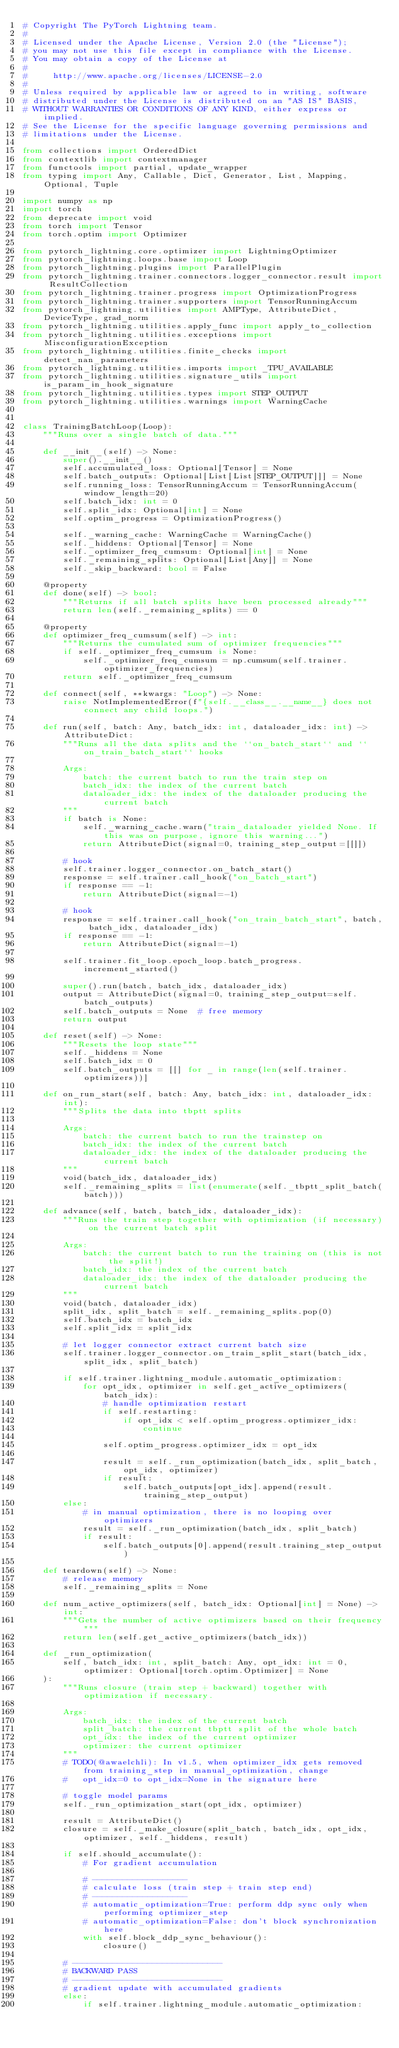<code> <loc_0><loc_0><loc_500><loc_500><_Python_># Copyright The PyTorch Lightning team.
#
# Licensed under the Apache License, Version 2.0 (the "License");
# you may not use this file except in compliance with the License.
# You may obtain a copy of the License at
#
#     http://www.apache.org/licenses/LICENSE-2.0
#
# Unless required by applicable law or agreed to in writing, software
# distributed under the License is distributed on an "AS IS" BASIS,
# WITHOUT WARRANTIES OR CONDITIONS OF ANY KIND, either express or implied.
# See the License for the specific language governing permissions and
# limitations under the License.

from collections import OrderedDict
from contextlib import contextmanager
from functools import partial, update_wrapper
from typing import Any, Callable, Dict, Generator, List, Mapping, Optional, Tuple

import numpy as np
import torch
from deprecate import void
from torch import Tensor
from torch.optim import Optimizer

from pytorch_lightning.core.optimizer import LightningOptimizer
from pytorch_lightning.loops.base import Loop
from pytorch_lightning.plugins import ParallelPlugin
from pytorch_lightning.trainer.connectors.logger_connector.result import ResultCollection
from pytorch_lightning.trainer.progress import OptimizationProgress
from pytorch_lightning.trainer.supporters import TensorRunningAccum
from pytorch_lightning.utilities import AMPType, AttributeDict, DeviceType, grad_norm
from pytorch_lightning.utilities.apply_func import apply_to_collection
from pytorch_lightning.utilities.exceptions import MisconfigurationException
from pytorch_lightning.utilities.finite_checks import detect_nan_parameters
from pytorch_lightning.utilities.imports import _TPU_AVAILABLE
from pytorch_lightning.utilities.signature_utils import is_param_in_hook_signature
from pytorch_lightning.utilities.types import STEP_OUTPUT
from pytorch_lightning.utilities.warnings import WarningCache


class TrainingBatchLoop(Loop):
    """Runs over a single batch of data."""

    def __init__(self) -> None:
        super().__init__()
        self.accumulated_loss: Optional[Tensor] = None
        self.batch_outputs: Optional[List[List[STEP_OUTPUT]]] = None
        self.running_loss: TensorRunningAccum = TensorRunningAccum(window_length=20)
        self.batch_idx: int = 0
        self.split_idx: Optional[int] = None
        self.optim_progress = OptimizationProgress()

        self._warning_cache: WarningCache = WarningCache()
        self._hiddens: Optional[Tensor] = None
        self._optimizer_freq_cumsum: Optional[int] = None
        self._remaining_splits: Optional[List[Any]] = None
        self._skip_backward: bool = False

    @property
    def done(self) -> bool:
        """Returns if all batch splits have been processed already"""
        return len(self._remaining_splits) == 0

    @property
    def optimizer_freq_cumsum(self) -> int:
        """Returns the cumulated sum of optimizer frequencies"""
        if self._optimizer_freq_cumsum is None:
            self._optimizer_freq_cumsum = np.cumsum(self.trainer.optimizer_frequencies)
        return self._optimizer_freq_cumsum

    def connect(self, **kwargs: "Loop") -> None:
        raise NotImplementedError(f"{self.__class__.__name__} does not connect any child loops.")

    def run(self, batch: Any, batch_idx: int, dataloader_idx: int) -> AttributeDict:
        """Runs all the data splits and the ``on_batch_start`` and ``on_train_batch_start`` hooks

        Args:
            batch: the current batch to run the train step on
            batch_idx: the index of the current batch
            dataloader_idx: the index of the dataloader producing the current batch
        """
        if batch is None:
            self._warning_cache.warn("train_dataloader yielded None. If this was on purpose, ignore this warning...")
            return AttributeDict(signal=0, training_step_output=[[]])

        # hook
        self.trainer.logger_connector.on_batch_start()
        response = self.trainer.call_hook("on_batch_start")
        if response == -1:
            return AttributeDict(signal=-1)

        # hook
        response = self.trainer.call_hook("on_train_batch_start", batch, batch_idx, dataloader_idx)
        if response == -1:
            return AttributeDict(signal=-1)

        self.trainer.fit_loop.epoch_loop.batch_progress.increment_started()

        super().run(batch, batch_idx, dataloader_idx)
        output = AttributeDict(signal=0, training_step_output=self.batch_outputs)
        self.batch_outputs = None  # free memory
        return output

    def reset(self) -> None:
        """Resets the loop state"""
        self._hiddens = None
        self.batch_idx = 0
        self.batch_outputs = [[] for _ in range(len(self.trainer.optimizers))]

    def on_run_start(self, batch: Any, batch_idx: int, dataloader_idx: int):
        """Splits the data into tbptt splits

        Args:
            batch: the current batch to run the trainstep on
            batch_idx: the index of the current batch
            dataloader_idx: the index of the dataloader producing the current batch
        """
        void(batch_idx, dataloader_idx)
        self._remaining_splits = list(enumerate(self._tbptt_split_batch(batch)))

    def advance(self, batch, batch_idx, dataloader_idx):
        """Runs the train step together with optimization (if necessary) on the current batch split

        Args:
            batch: the current batch to run the training on (this is not the split!)
            batch_idx: the index of the current batch
            dataloader_idx: the index of the dataloader producing the current batch
        """
        void(batch, dataloader_idx)
        split_idx, split_batch = self._remaining_splits.pop(0)
        self.batch_idx = batch_idx
        self.split_idx = split_idx

        # let logger connector extract current batch size
        self.trainer.logger_connector.on_train_split_start(batch_idx, split_idx, split_batch)

        if self.trainer.lightning_module.automatic_optimization:
            for opt_idx, optimizer in self.get_active_optimizers(batch_idx):
                # handle optimization restart
                if self.restarting:
                    if opt_idx < self.optim_progress.optimizer_idx:
                        continue

                self.optim_progress.optimizer_idx = opt_idx

                result = self._run_optimization(batch_idx, split_batch, opt_idx, optimizer)
                if result:
                    self.batch_outputs[opt_idx].append(result.training_step_output)
        else:
            # in manual optimization, there is no looping over optimizers
            result = self._run_optimization(batch_idx, split_batch)
            if result:
                self.batch_outputs[0].append(result.training_step_output)

    def teardown(self) -> None:
        # release memory
        self._remaining_splits = None

    def num_active_optimizers(self, batch_idx: Optional[int] = None) -> int:
        """Gets the number of active optimizers based on their frequency"""
        return len(self.get_active_optimizers(batch_idx))

    def _run_optimization(
        self, batch_idx: int, split_batch: Any, opt_idx: int = 0, optimizer: Optional[torch.optim.Optimizer] = None
    ):
        """Runs closure (train step + backward) together with optimization if necessary.

        Args:
            batch_idx: the index of the current batch
            split_batch: the current tbptt split of the whole batch
            opt_idx: the index of the current optimizer
            optimizer: the current optimizer
        """
        # TODO(@awaelchli): In v1.5, when optimizer_idx gets removed from training_step in manual_optimization, change
        #   opt_idx=0 to opt_idx=None in the signature here

        # toggle model params
        self._run_optimization_start(opt_idx, optimizer)

        result = AttributeDict()
        closure = self._make_closure(split_batch, batch_idx, opt_idx, optimizer, self._hiddens, result)

        if self.should_accumulate():
            # For gradient accumulation

            # -------------------
            # calculate loss (train step + train step end)
            # -------------------
            # automatic_optimization=True: perform ddp sync only when performing optimizer_step
            # automatic_optimization=False: don't block synchronization here
            with self.block_ddp_sync_behaviour():
                closure()

        # ------------------------------
        # BACKWARD PASS
        # ------------------------------
        # gradient update with accumulated gradients
        else:
            if self.trainer.lightning_module.automatic_optimization:</code> 